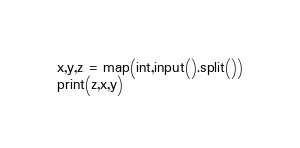<code> <loc_0><loc_0><loc_500><loc_500><_Python_>x,y,z = map(int,input().split())
print(z,x,y)</code> 